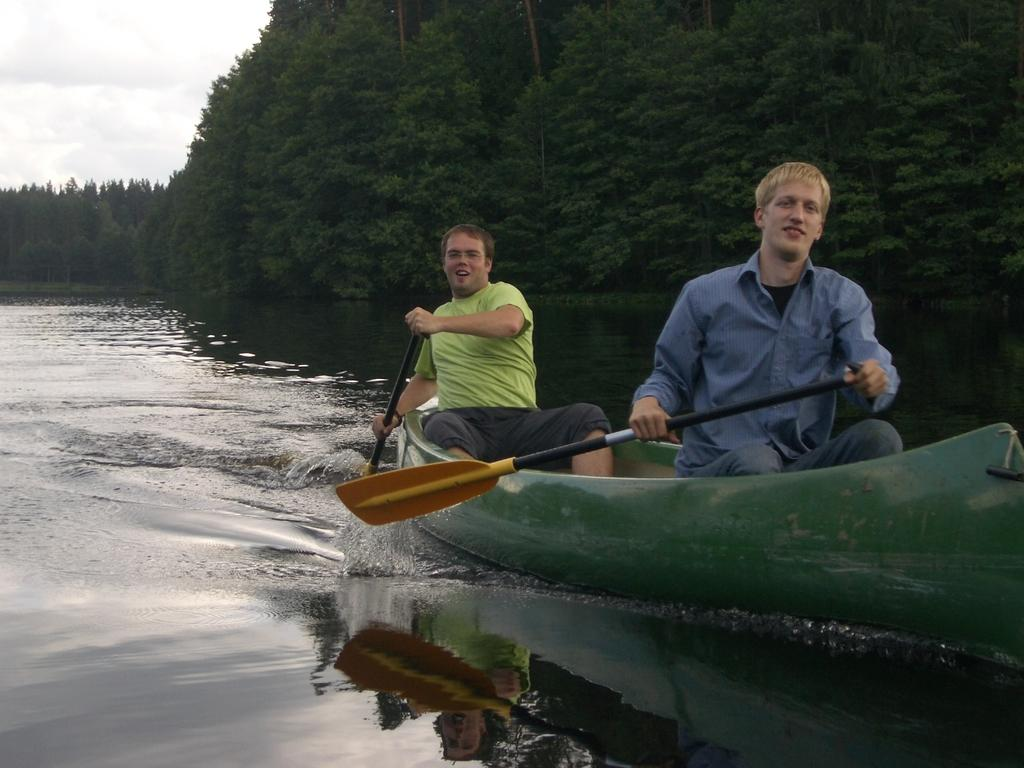What is the main subject of the image? The main subject of the image is water. What is located in the water? There is a boat in the water. Who is riding the boat? Two persons are riding the boat. What are the persons holding? The persons are holding sticks. What can be seen in the background of the image? There are trees and the sky visible in the background of the image. What is the condition of the sky in the image? Clouds are present in the sky. What flavor of ice cream are the persons eating while riding the boat in the image? There is no ice cream present in the image; the persons are holding sticks, not eating ice cream. 